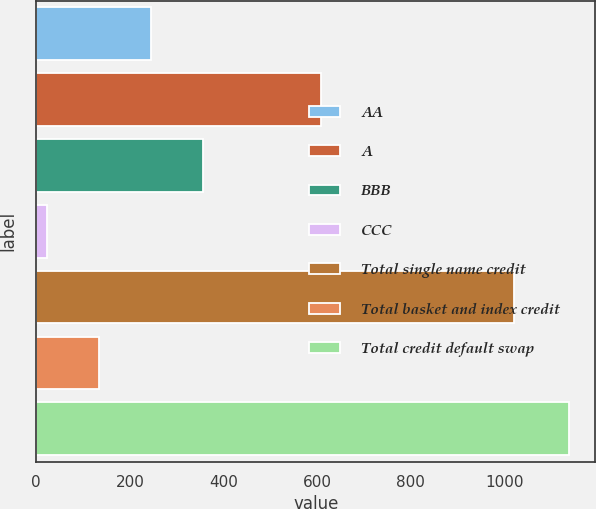<chart> <loc_0><loc_0><loc_500><loc_500><bar_chart><fcel>AA<fcel>A<fcel>BBB<fcel>CCC<fcel>Total single name credit<fcel>Total basket and index credit<fcel>Total credit default swap<nl><fcel>245.18<fcel>609<fcel>356.77<fcel>22<fcel>1021.9<fcel>133.59<fcel>1137.9<nl></chart> 